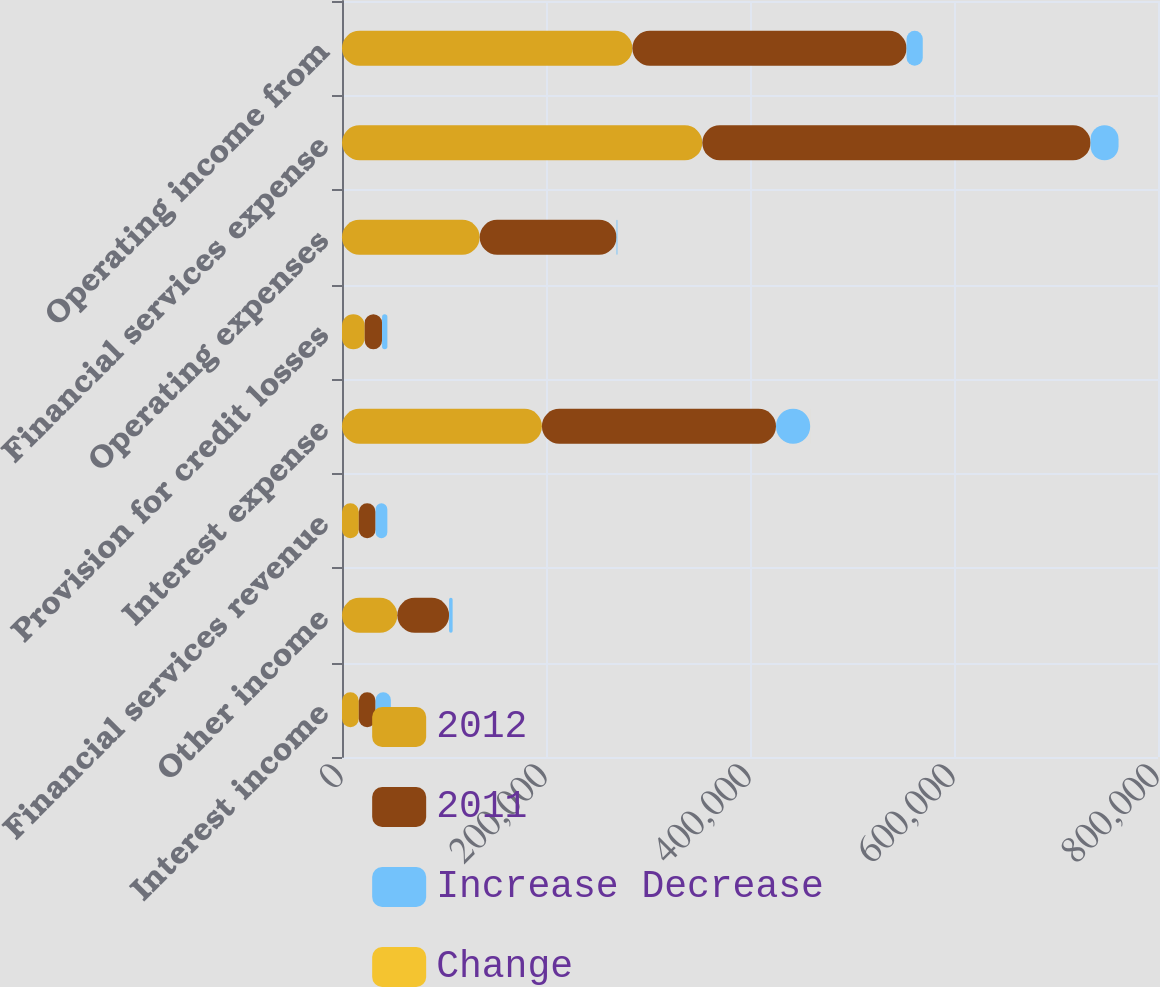<chart> <loc_0><loc_0><loc_500><loc_500><stacked_bar_chart><ecel><fcel>Interest income<fcel>Other income<fcel>Financial services revenue<fcel>Interest expense<fcel>Provision for credit losses<fcel>Operating expenses<fcel>Financial services expense<fcel>Operating income from<nl><fcel>2012<fcel>16463.5<fcel>54224<fcel>16463.5<fcel>195990<fcel>22239<fcel>135008<fcel>353237<fcel>284687<nl><fcel>2011<fcel>16463.5<fcel>50774<fcel>16463.5<fcel>229492<fcel>17031<fcel>134135<fcel>380658<fcel>268791<nl><fcel>Increase Decrease<fcel>14975<fcel>3450<fcel>11525<fcel>33502<fcel>5208<fcel>873<fcel>27421<fcel>15896<nl><fcel>Change<fcel>2.5<fcel>6.8<fcel>1.8<fcel>14.6<fcel>30.6<fcel>0.7<fcel>7.2<fcel>5.9<nl></chart> 